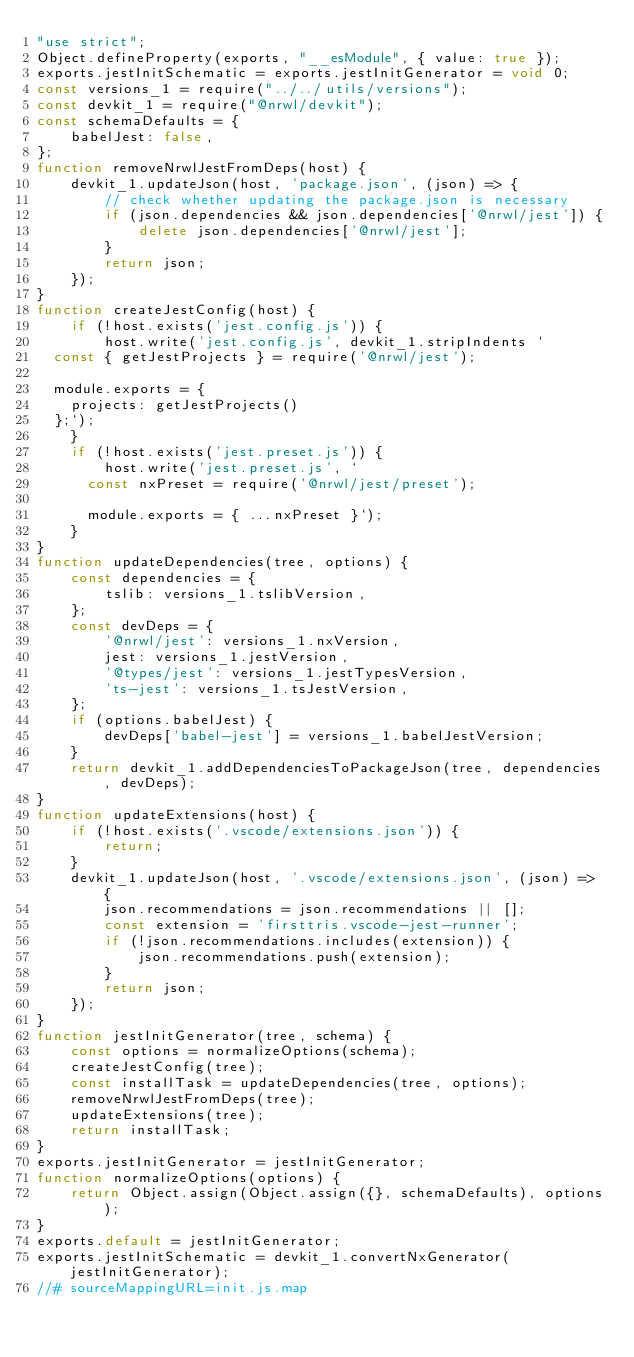Convert code to text. <code><loc_0><loc_0><loc_500><loc_500><_JavaScript_>"use strict";
Object.defineProperty(exports, "__esModule", { value: true });
exports.jestInitSchematic = exports.jestInitGenerator = void 0;
const versions_1 = require("../../utils/versions");
const devkit_1 = require("@nrwl/devkit");
const schemaDefaults = {
    babelJest: false,
};
function removeNrwlJestFromDeps(host) {
    devkit_1.updateJson(host, 'package.json', (json) => {
        // check whether updating the package.json is necessary
        if (json.dependencies && json.dependencies['@nrwl/jest']) {
            delete json.dependencies['@nrwl/jest'];
        }
        return json;
    });
}
function createJestConfig(host) {
    if (!host.exists('jest.config.js')) {
        host.write('jest.config.js', devkit_1.stripIndents `
  const { getJestProjects } = require('@nrwl/jest');

  module.exports = {
    projects: getJestProjects()
  };`);
    }
    if (!host.exists('jest.preset.js')) {
        host.write('jest.preset.js', `
      const nxPreset = require('@nrwl/jest/preset');
     
      module.exports = { ...nxPreset }`);
    }
}
function updateDependencies(tree, options) {
    const dependencies = {
        tslib: versions_1.tslibVersion,
    };
    const devDeps = {
        '@nrwl/jest': versions_1.nxVersion,
        jest: versions_1.jestVersion,
        '@types/jest': versions_1.jestTypesVersion,
        'ts-jest': versions_1.tsJestVersion,
    };
    if (options.babelJest) {
        devDeps['babel-jest'] = versions_1.babelJestVersion;
    }
    return devkit_1.addDependenciesToPackageJson(tree, dependencies, devDeps);
}
function updateExtensions(host) {
    if (!host.exists('.vscode/extensions.json')) {
        return;
    }
    devkit_1.updateJson(host, '.vscode/extensions.json', (json) => {
        json.recommendations = json.recommendations || [];
        const extension = 'firsttris.vscode-jest-runner';
        if (!json.recommendations.includes(extension)) {
            json.recommendations.push(extension);
        }
        return json;
    });
}
function jestInitGenerator(tree, schema) {
    const options = normalizeOptions(schema);
    createJestConfig(tree);
    const installTask = updateDependencies(tree, options);
    removeNrwlJestFromDeps(tree);
    updateExtensions(tree);
    return installTask;
}
exports.jestInitGenerator = jestInitGenerator;
function normalizeOptions(options) {
    return Object.assign(Object.assign({}, schemaDefaults), options);
}
exports.default = jestInitGenerator;
exports.jestInitSchematic = devkit_1.convertNxGenerator(jestInitGenerator);
//# sourceMappingURL=init.js.map</code> 